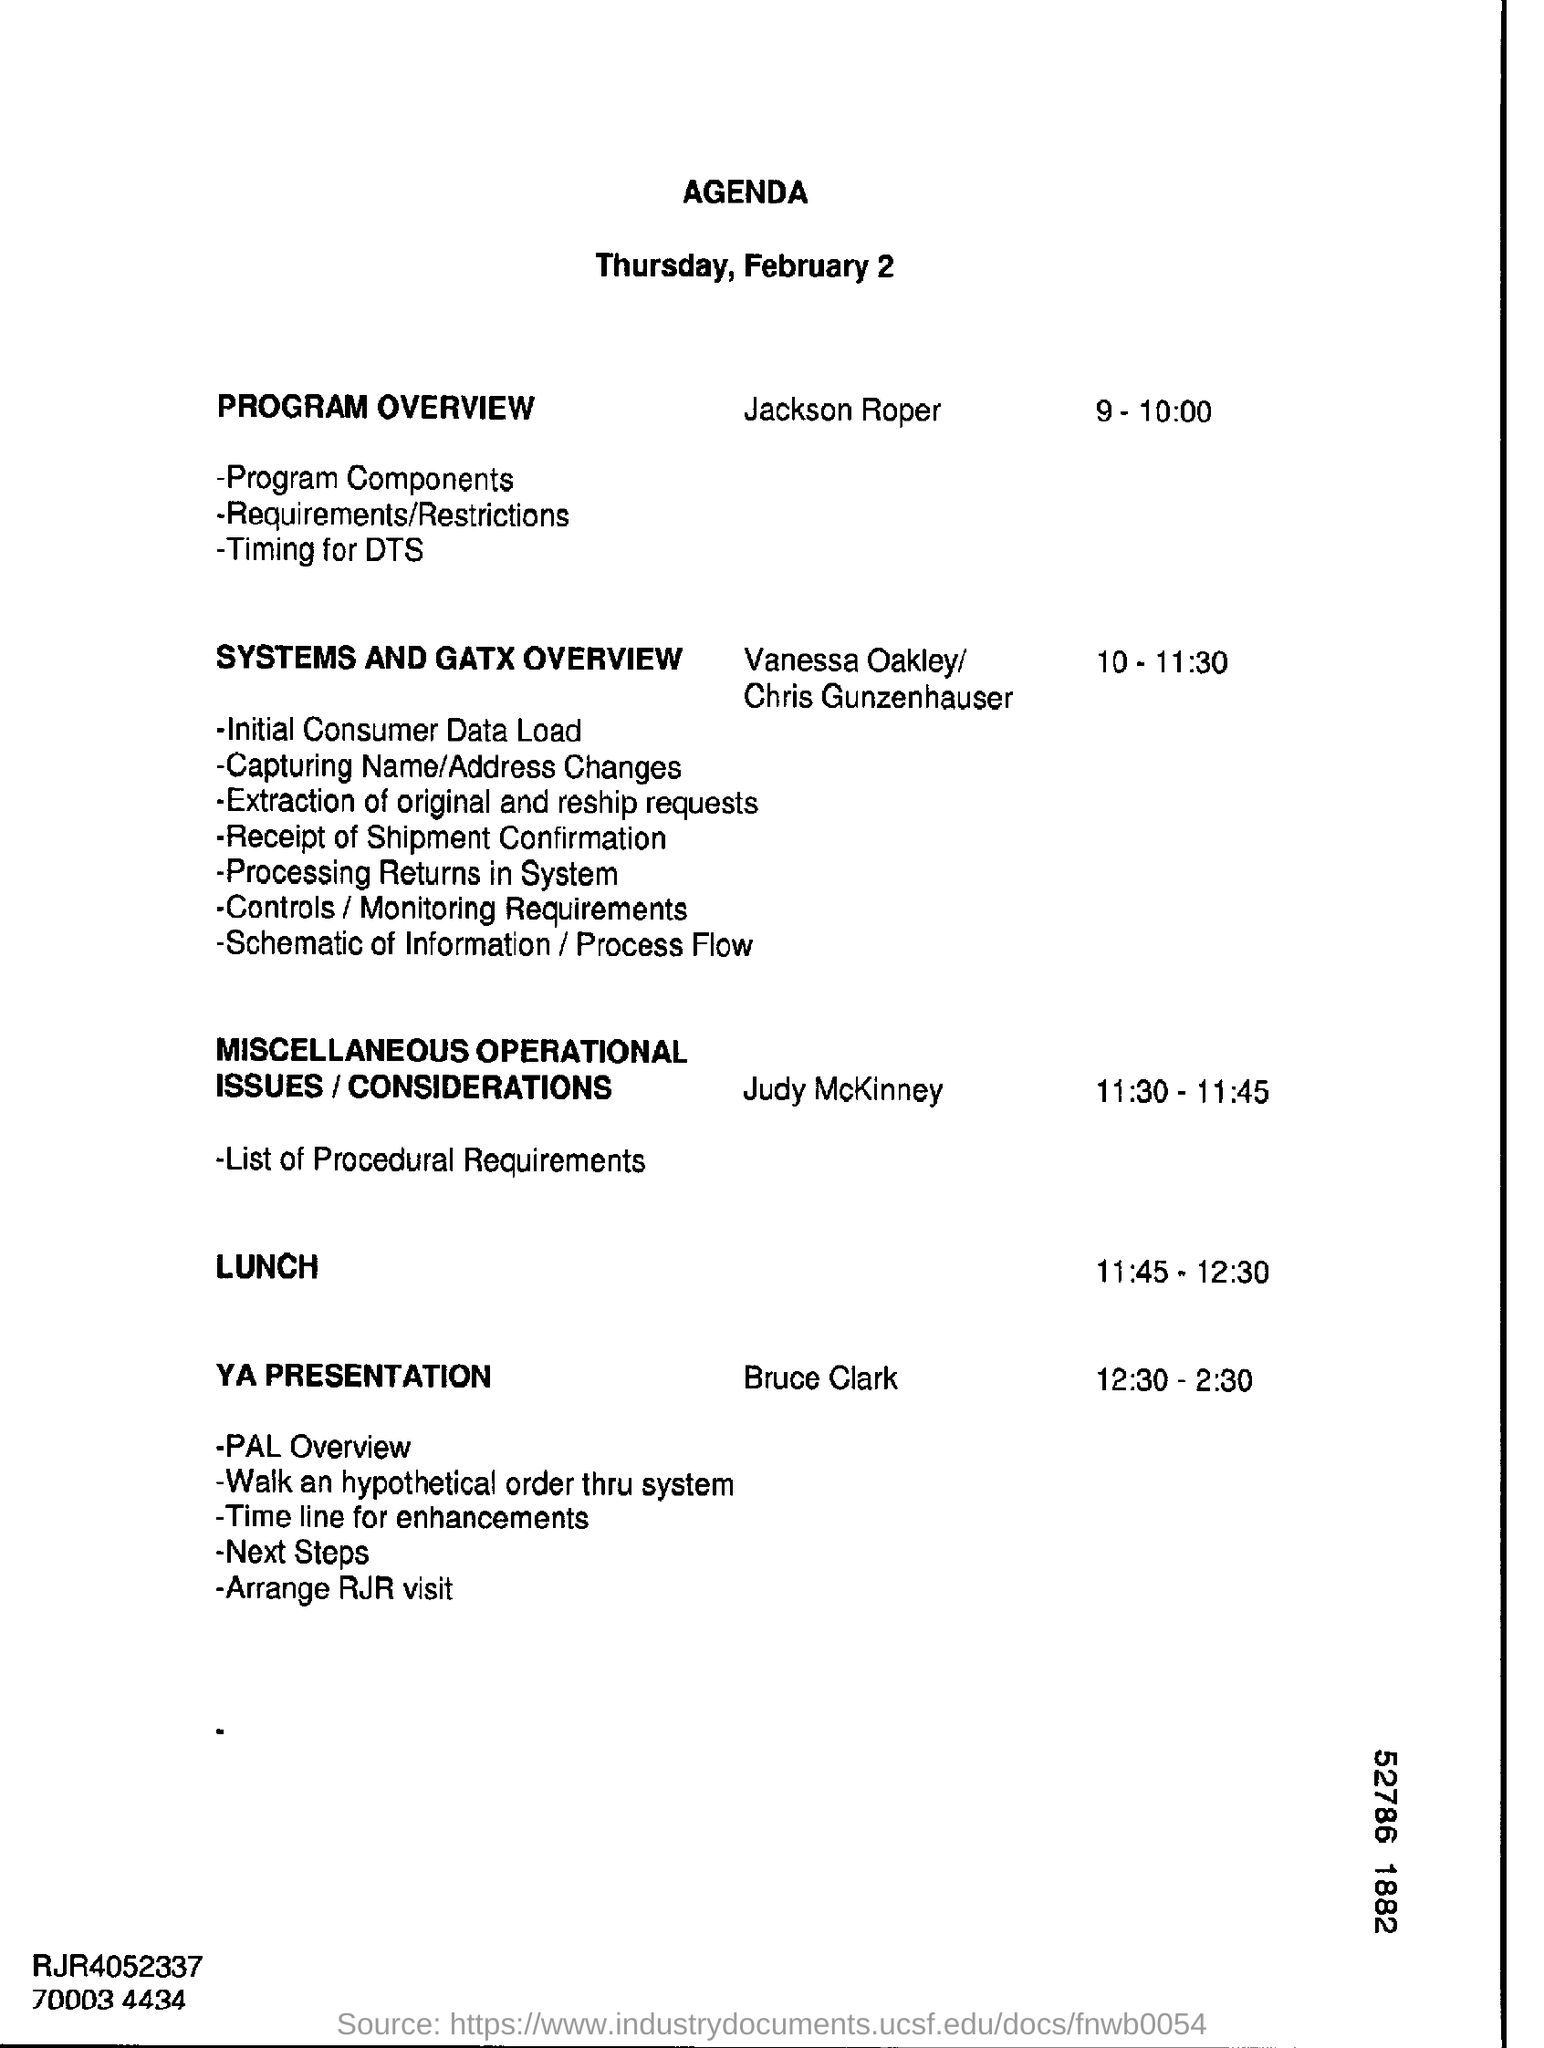Mention a couple of crucial points in this snapshot. The document mentions that the date is February 2nd. Vanessa Oakley and Chris Gunzenhauser are dealing with systems and are familiar with GATX overview. 